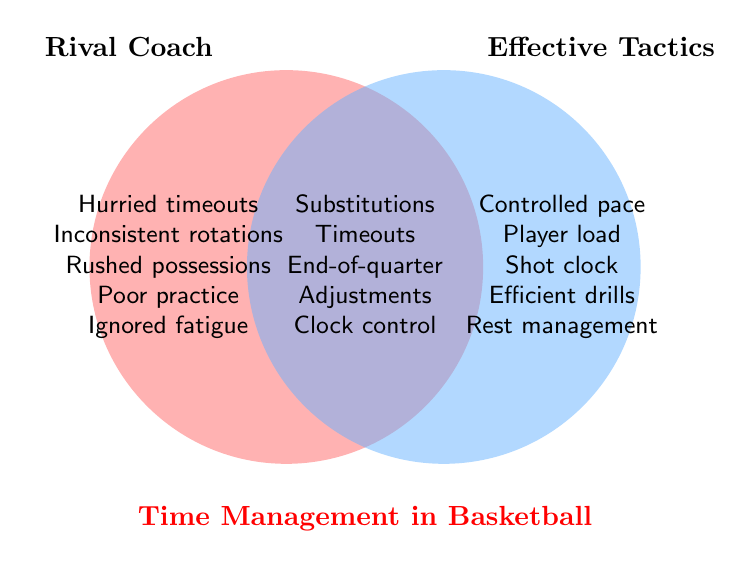Which coach's tactics involve hurried timeouts? The category "Rival Coach" contains "Hurried timeouts".
Answer: Rival Coach What is one effective tactic that involves handling the shot clock? The category "Effective Tactics" lists "Shot clock awareness".
Answer: Shot clock awareness Which section of the Venn Diagram contains "Clock manipulation"? The intersection section includes "Clock manipulation".
Answer: Intersection How many time management tactics are listed under "Rival Coach"? By counting the items under "Rival Coach" section, there are 5: "Hurried timeouts", "Inconsistent rotations", "Rushed possessions", "Poor practice scheduling", "Ignored fatigue signs".
Answer: 5 Is "Rest management" an effective tactic or a rival coach's strategy? "Rest management" is under the "Effective Tactics" section.
Answer: Effective Tactics Which group of tactics share "Strategic substitutions"? "Strategic substitutions" is listed in the intersection, meaning it is shared by both the "Rival Coach" and "Effective Tactics" groups.
Answer: Both Compare the number of unique tactics between "Rival Coach" and "Effective Tactics". Which group has more? "Rival Coach" has 5 unique tactics, "Effective Tactics" also has 5 unique tactics. They have an equal number of unique tactics.
Answer: Equal What is a common aspect of time management in basketball shared by both groups? Listed in the intersection are "Strategic substitutions", "Timeout usage", "End-of-quarter plays", "In-game adjustments", "Clock manipulation". Any of these can be a correct answer.
Answer: Any intersect item 